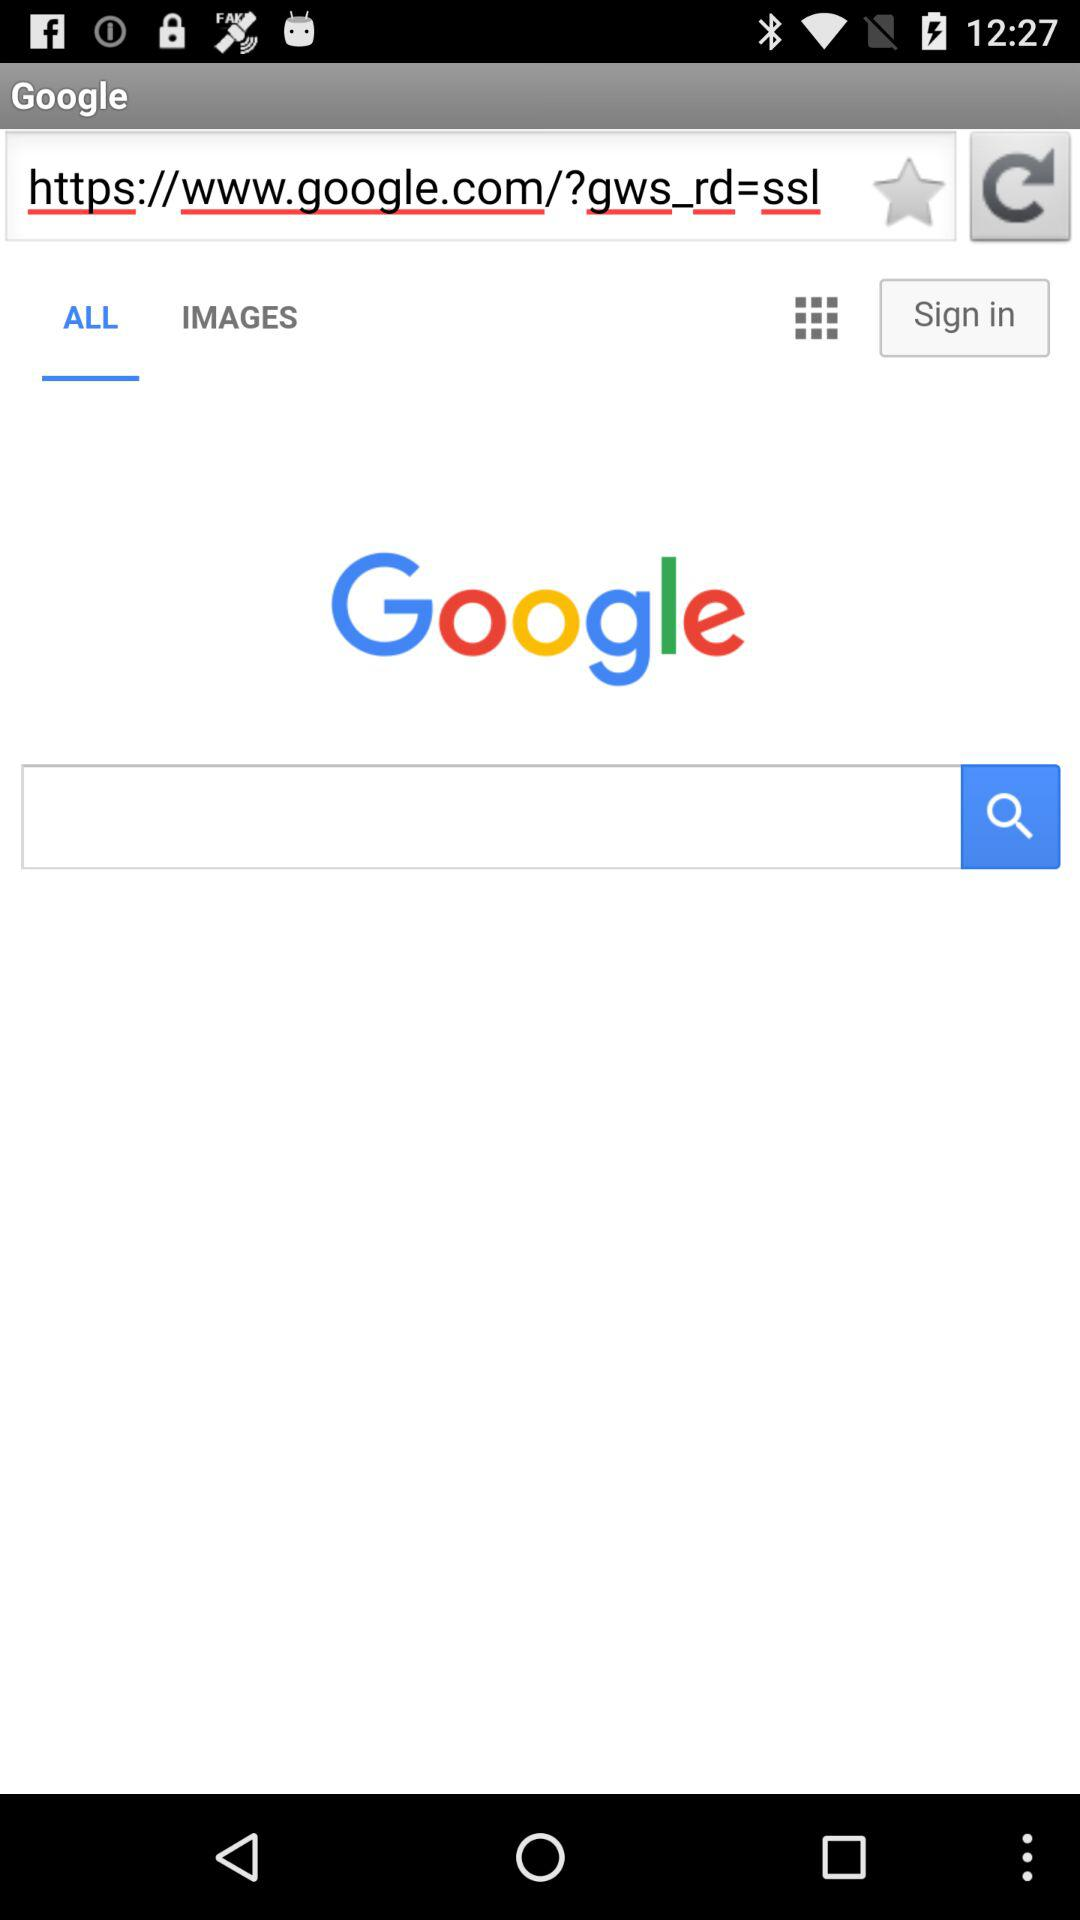What is the application name? The application name is "Google". 